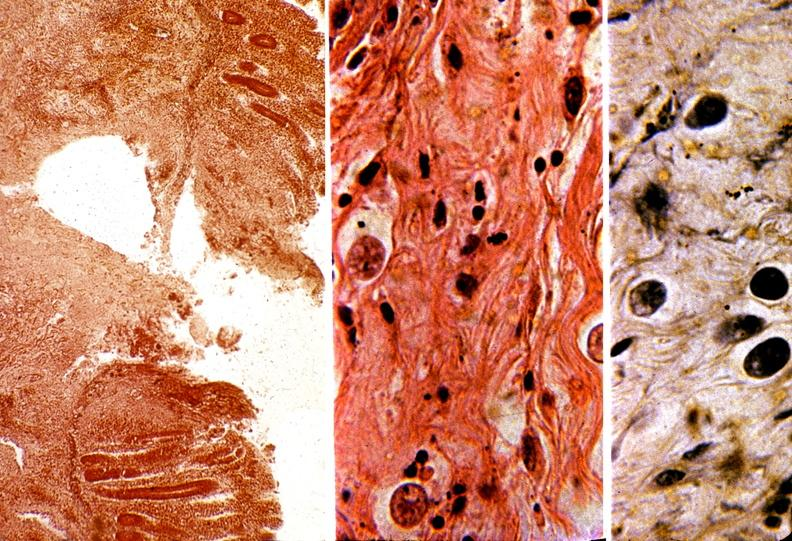s leiomyoma present?
Answer the question using a single word or phrase. No 